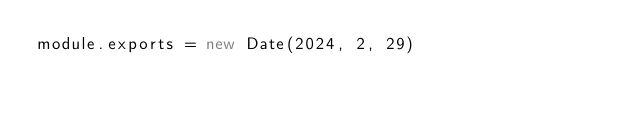Convert code to text. <code><loc_0><loc_0><loc_500><loc_500><_JavaScript_>module.exports = new Date(2024, 2, 29)
</code> 